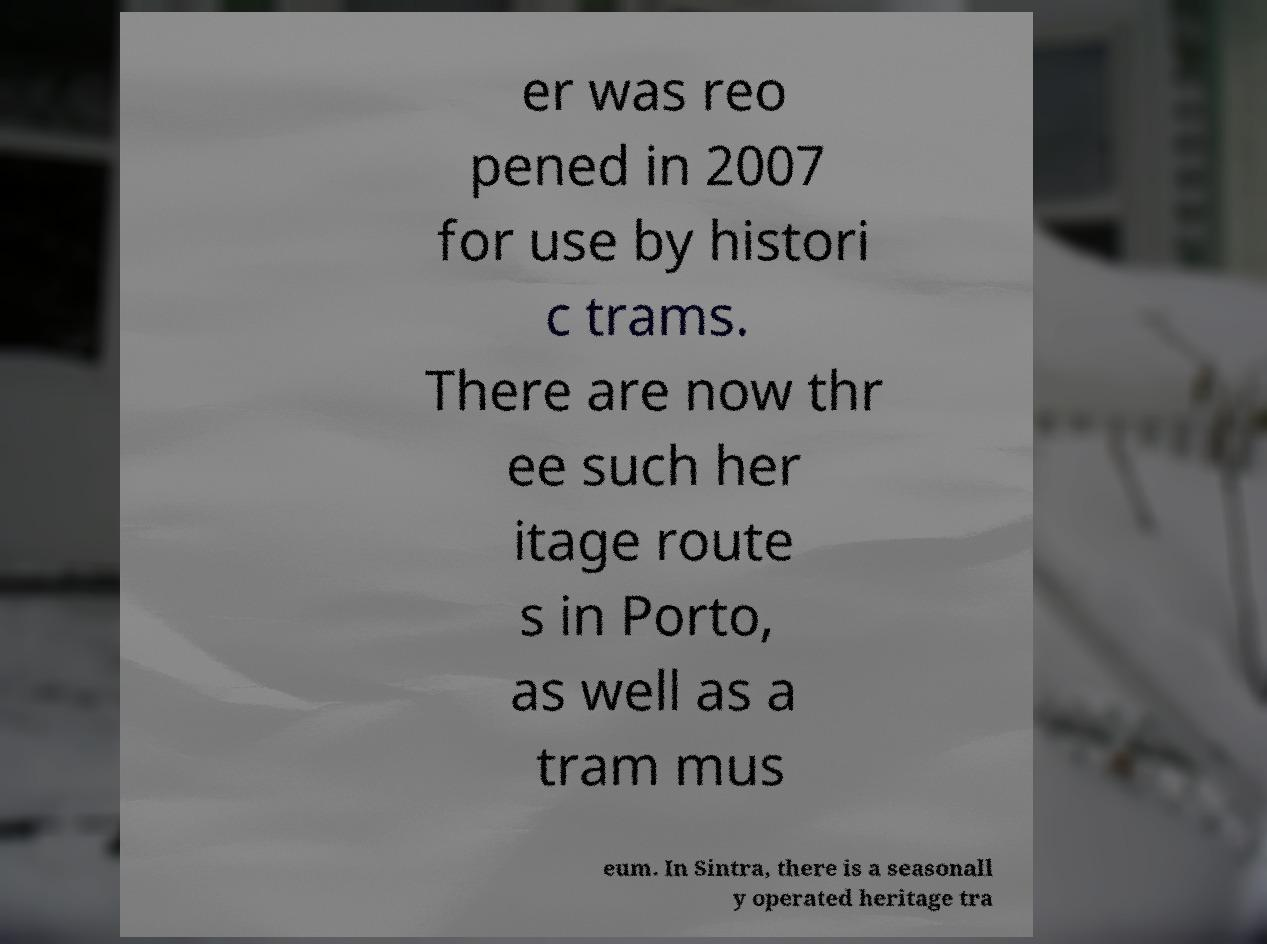Can you read and provide the text displayed in the image?This photo seems to have some interesting text. Can you extract and type it out for me? er was reo pened in 2007 for use by histori c trams. There are now thr ee such her itage route s in Porto, as well as a tram mus eum. In Sintra, there is a seasonall y operated heritage tra 